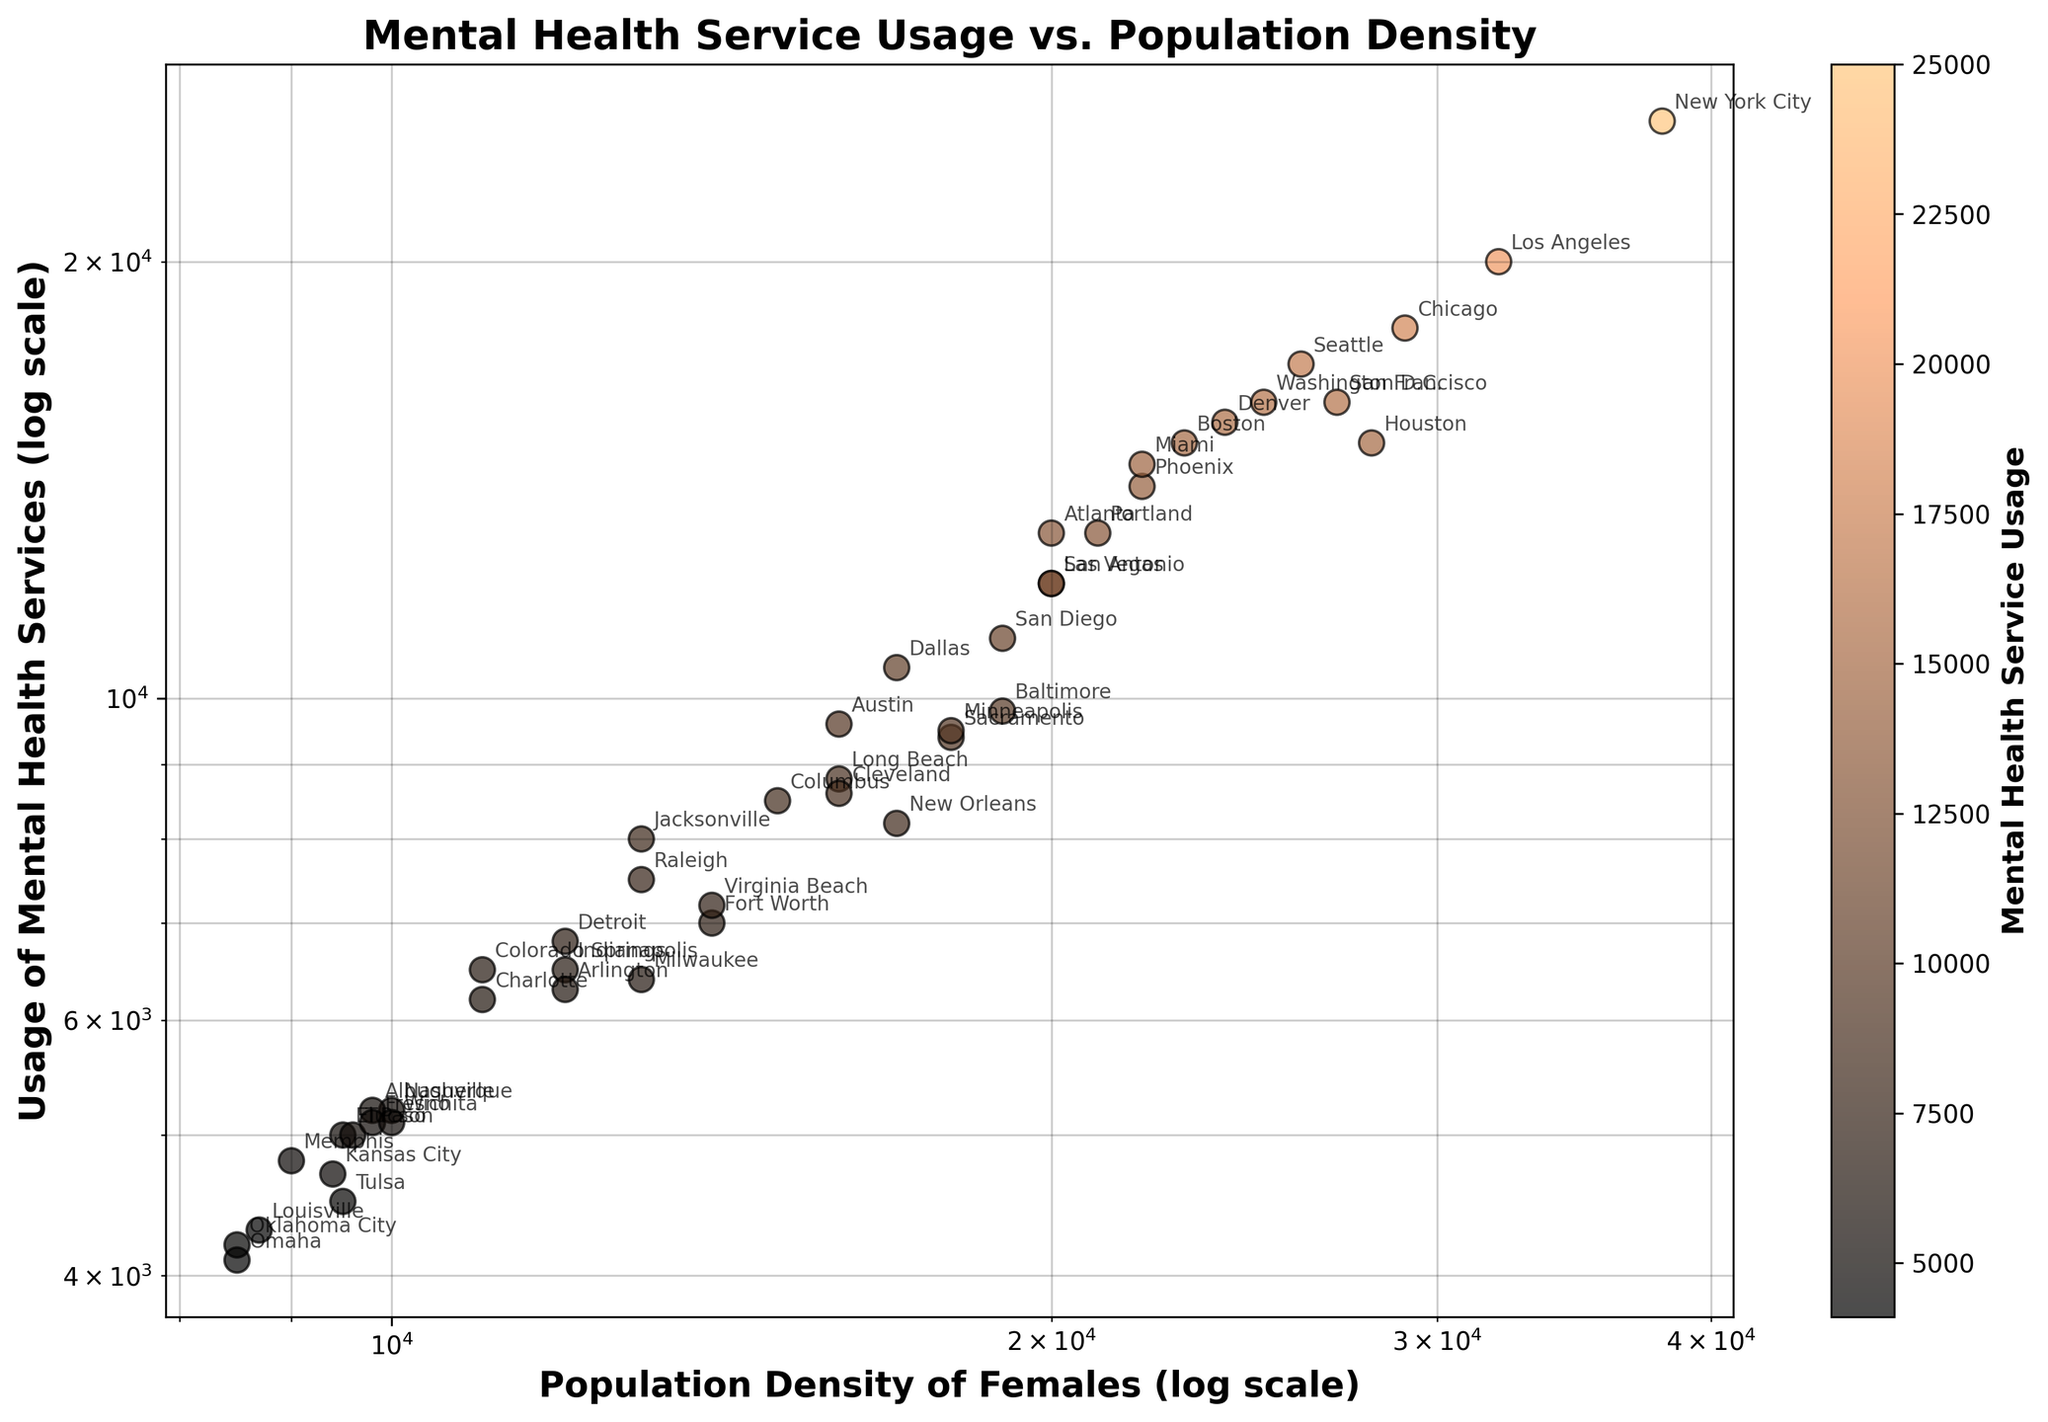What is the title of the scatter plot? The title of the scatter plot can be found at the top center of the figure. It is usually in bold and larger font compared to other text in the figure.
Answer: Mental Health Service Usage vs. Population Density How many data points are displayed in the plot? To find the number of data points, one needs to count each individual scatter point on the plot. In this case, there are 46 scatter points representing different areas.
Answer: 46 Which area has the highest usage of mental health services? The area with the highest usage will be the scatter point that is located farthest up on the y-axis. For this figure, it is New York City.
Answer: New York City What urban area has a lower usage of mental health services than San Diego? Look for data points that are more to the left of San Diego (19000 population density, 11000 usage), and then below it on the y-axis. Dallas is such an area with a lower value.
Answer: Dallas What is the median value of Population Density of Females for the areas plotted? Arrange all the population density values in ascending order and find the middle value. Given there are 46 areas, the median will be the average of the 23rd and 24th values. For quick reference, select the 23rd and 24th values which are 11000 and 12000 respectively. The median is (11000 + 12000)/2.
Answer: 11500 Do rural areas generally have lower or higher usage of mental health services compared to urban areas? By observing the distribution of data points, data points on the left side of the plot (lower population density) tend to also be lower on the y-axis, indicating lower usage of mental health services.
Answer: Lower Which area has the closest pairing of population density of females and usage of mental health services? To find the closest pairing, look for scatter points where the x and y coordinates are closest to each other. San Diego (19000, 11000) or Columbus (15000, 8500) could be evaluated as close pairings.
Answer: San Diego Are there any outliers in the scatter plot? If so, which areas are they? Outliers are points that significantly differ from the pattern of the rest of the data. In this plot, New York City (38000, 25000) and Los Angeles (32000, 20000) are considerably higher in both population density and mental health service usage compared to other areas.
Answer: New York City, Los Angeles Is there a positive or negative correlation between population density of females and usage of mental health services? By observing the overall trend of the scatter points, you can determine if the points generally move upwards (positive correlation) or downwards (negative correlation) as the x-value increases. Here it shows a positive correlation.
Answer: Positive Which areas have similar usage of mental health services as Austin? Identify points on the plot that have a similar y-value to Austin (9600 usage). Potential similar areas include Baltimore (9800) and Cleveland (8600).
Answer: Baltimore, Cleveland 